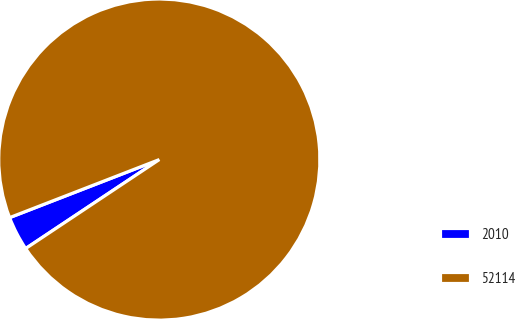Convert chart to OTSL. <chart><loc_0><loc_0><loc_500><loc_500><pie_chart><fcel>2010<fcel>52114<nl><fcel>3.46%<fcel>96.54%<nl></chart> 